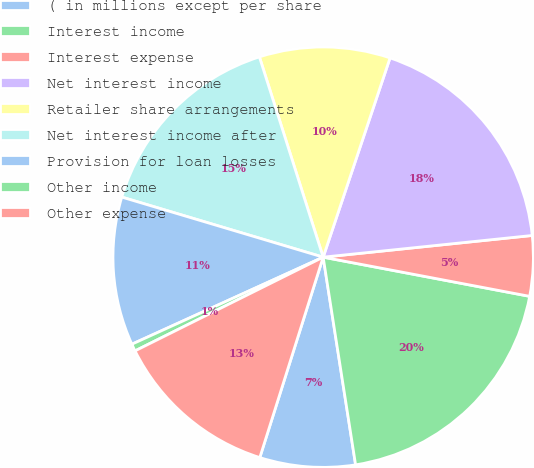Convert chart. <chart><loc_0><loc_0><loc_500><loc_500><pie_chart><fcel>( in millions except per share<fcel>Interest income<fcel>Interest expense<fcel>Net interest income<fcel>Retailer share arrangements<fcel>Net interest income after<fcel>Provision for loan losses<fcel>Other income<fcel>Other expense<nl><fcel>7.34%<fcel>19.55%<fcel>4.63%<fcel>18.2%<fcel>10.06%<fcel>15.48%<fcel>11.41%<fcel>0.56%<fcel>12.77%<nl></chart> 